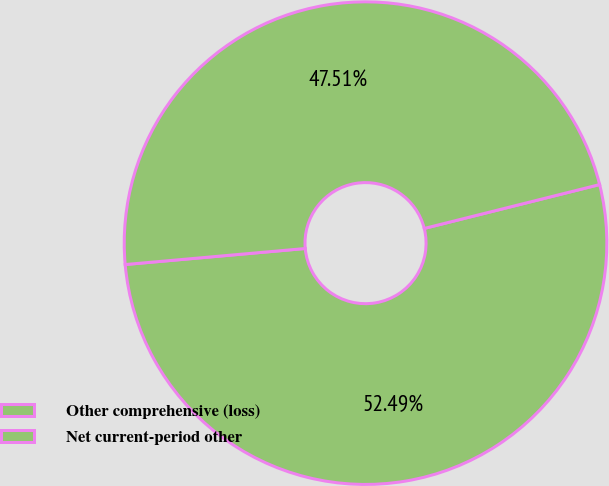<chart> <loc_0><loc_0><loc_500><loc_500><pie_chart><fcel>Other comprehensive (loss)<fcel>Net current-period other<nl><fcel>52.49%<fcel>47.51%<nl></chart> 